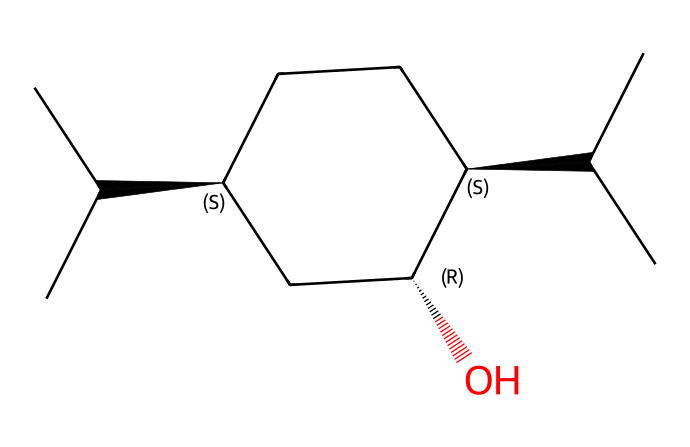how many carbon atoms are in the structure? Count the carbon (C) atoms in the SMILES representation. In the given SMILES, the notation indicates 10 carbons including side chains and cyclic structure.
Answer: 10 what functional group is present in menthol? Look for groups in the structure that define its chemical behavior. The presence of the hydroxyl group (-OH) indicates a presence of an alcohol functional group.
Answer: alcohol how many chiral centers are present in the chemical structure? Identify the carbon atoms that have four different groups attached in the rendered structure. In menthol, there are three stereogenic centers, indicating three chiral centers.
Answer: 3 what type of chemical is menthol primarily classified as? Evaluate the structure and recognize its use and characteristics. Menthol is primarily classified as a terpenoid due to its structure and natural occurrence, especially in mint.
Answer: terpenoid which part of the chemical structure gives menthol its cooling sensation? Examine the structure for specific groups contributing to perceived sensations. The alcohol functional group and the spatial arrangement of the structure lead to the cooling sensation experienced when applied topically.
Answer: alcohol 